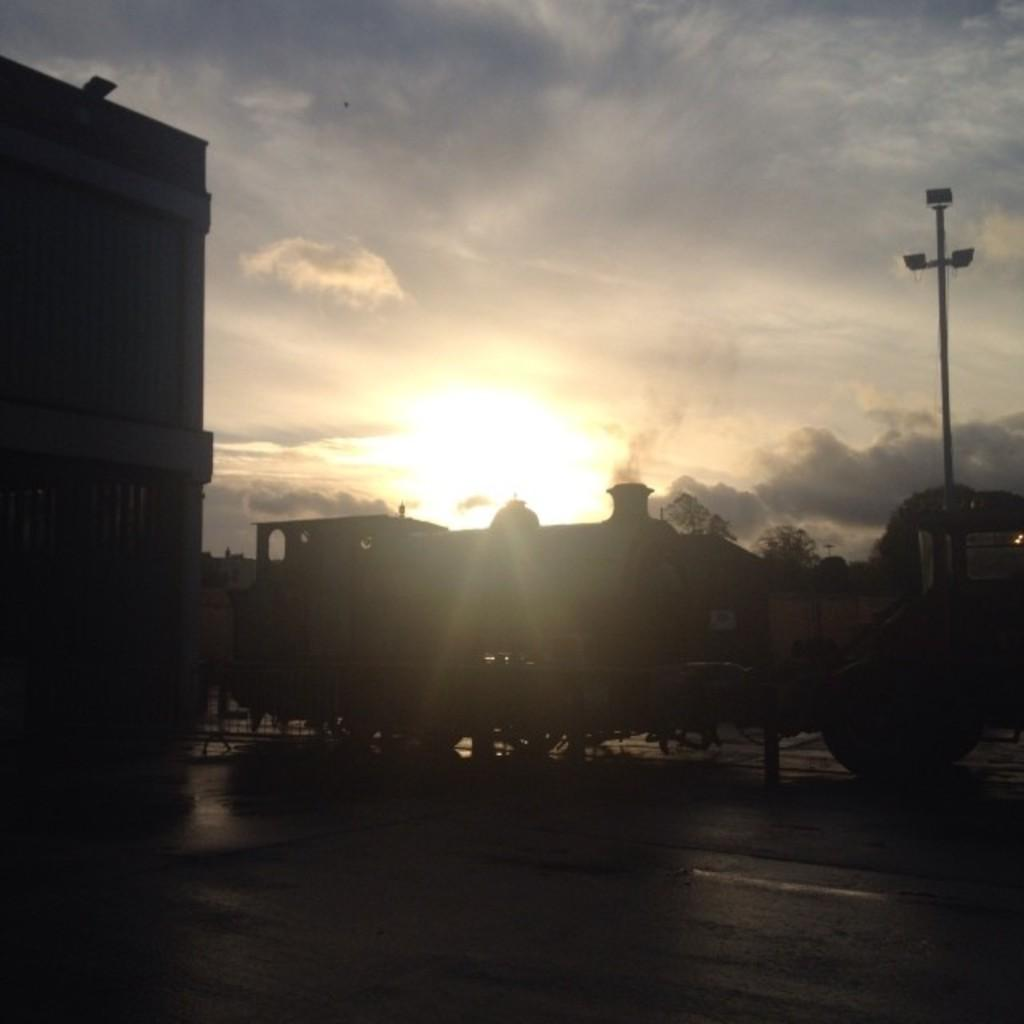What is located in the center of the image? There are vehicles in the center of the image. What can be seen in the background of the image? There are buildings and trees in the background of the image. What is the condition of the sky in the image? The sky is cloudy in the image. What is on the right side of the image? There is a pole on the right side of the image. What type of apparel is the laborer wearing in the image? There is no laborer or apparel present in the image. What flavor of soda can be seen in the image? There is no soda present in the image. 